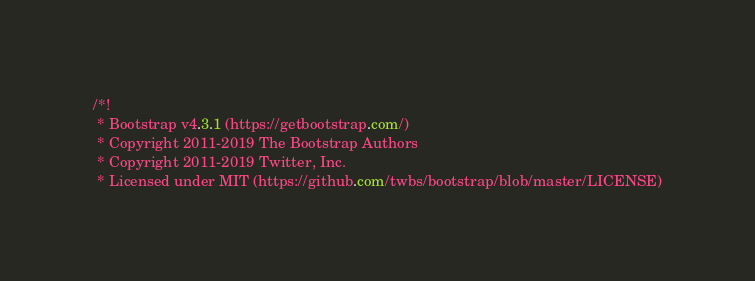Convert code to text. <code><loc_0><loc_0><loc_500><loc_500><_CSS_>/*!
 * Bootstrap v4.3.1 (https://getbootstrap.com/)
 * Copyright 2011-2019 The Bootstrap Authors
 * Copyright 2011-2019 Twitter, Inc.
 * Licensed under MIT (https://github.com/twbs/bootstrap/blob/master/LICENSE)</code> 